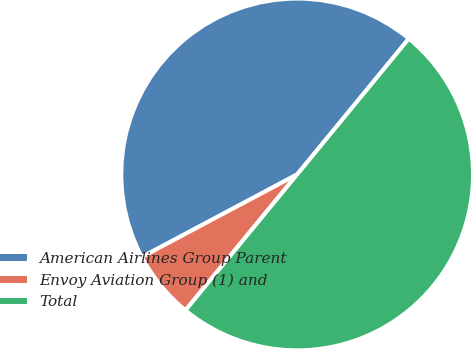Convert chart. <chart><loc_0><loc_0><loc_500><loc_500><pie_chart><fcel>American Airlines Group Parent<fcel>Envoy Aviation Group (1) and<fcel>Total<nl><fcel>43.73%<fcel>6.27%<fcel>50.0%<nl></chart> 